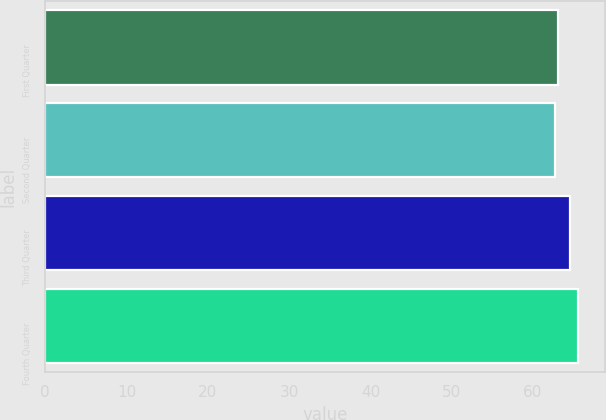<chart> <loc_0><loc_0><loc_500><loc_500><bar_chart><fcel>First Quarter<fcel>Second Quarter<fcel>Third Quarter<fcel>Fourth Quarter<nl><fcel>63.03<fcel>62.68<fcel>64.53<fcel>65.56<nl></chart> 